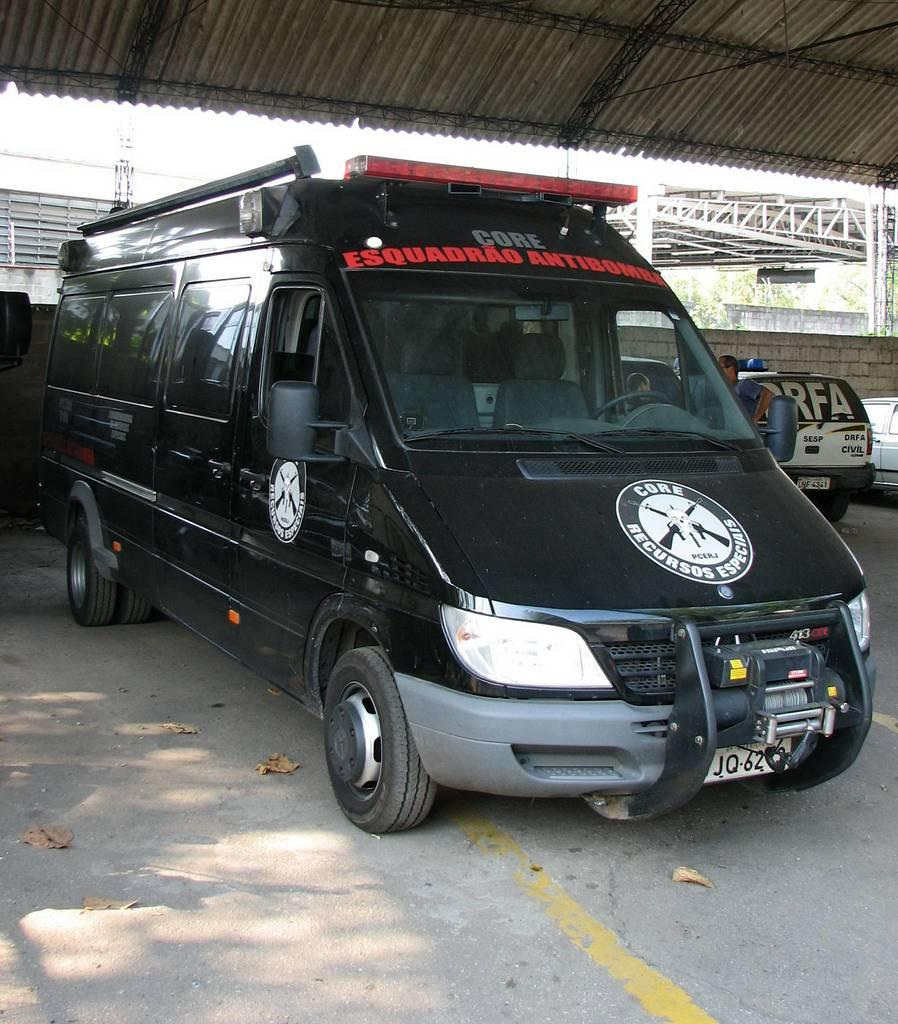What can be seen in the image? There are vehicles and persons standing in the middle of the image. What is the purpose of the shelter visible at the top of the image? The purpose of the shelter is not specified in the image, but it could provide shade or shelter from the elements. How many frogs are hopping on the vehicles in the image? There are no frogs present in the image; it only features vehicles and persons standing in the middle. 